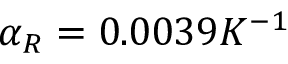Convert formula to latex. <formula><loc_0><loc_0><loc_500><loc_500>\alpha _ { R } = 0 . 0 0 3 9 K ^ { - 1 }</formula> 